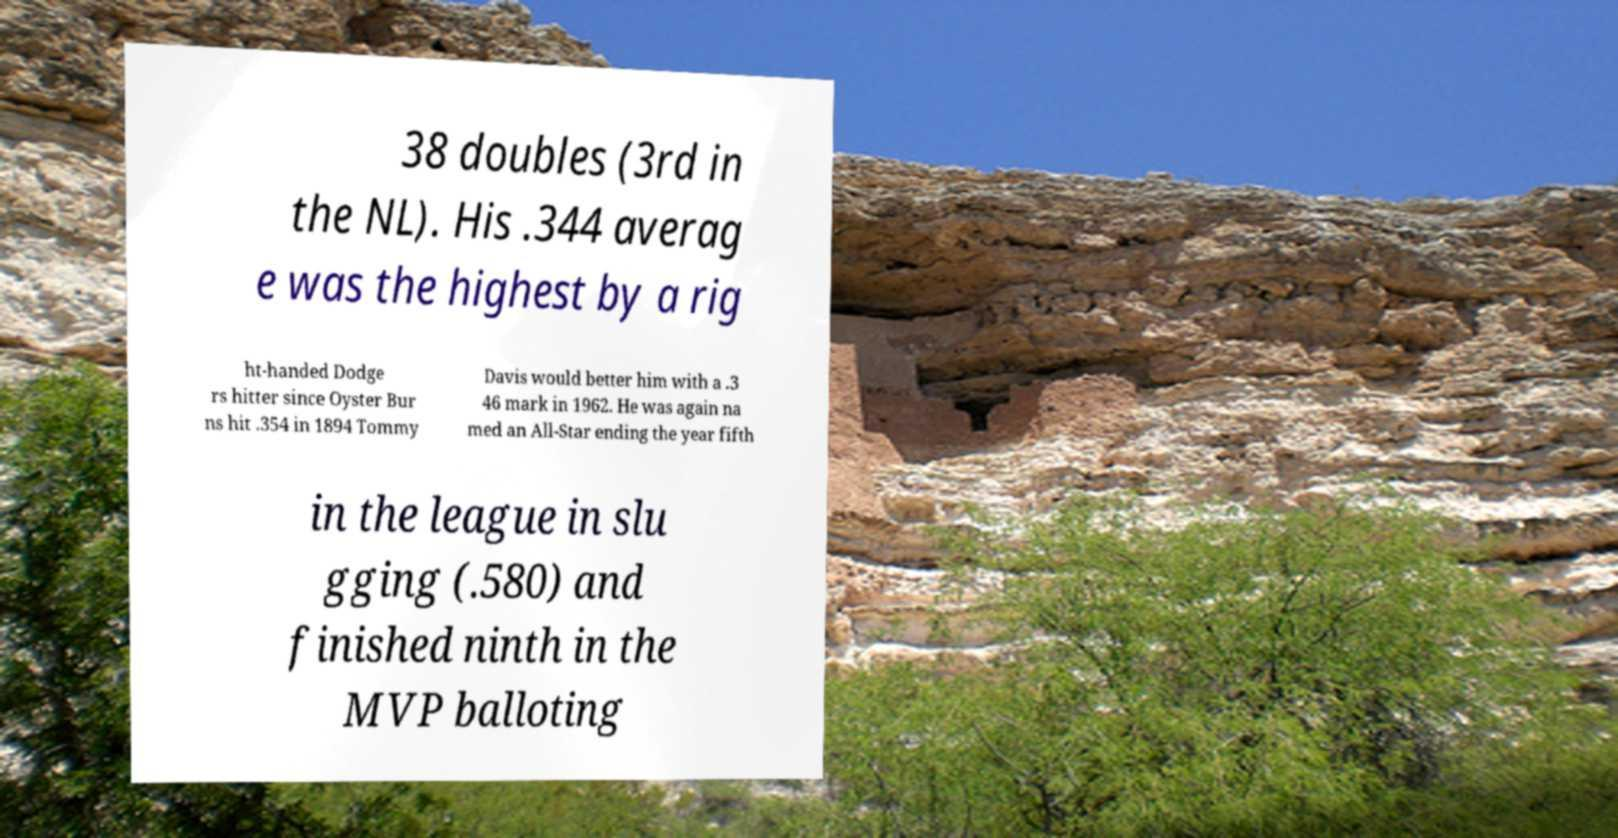What messages or text are displayed in this image? I need them in a readable, typed format. 38 doubles (3rd in the NL). His .344 averag e was the highest by a rig ht-handed Dodge rs hitter since Oyster Bur ns hit .354 in 1894 Tommy Davis would better him with a .3 46 mark in 1962. He was again na med an All-Star ending the year fifth in the league in slu gging (.580) and finished ninth in the MVP balloting 